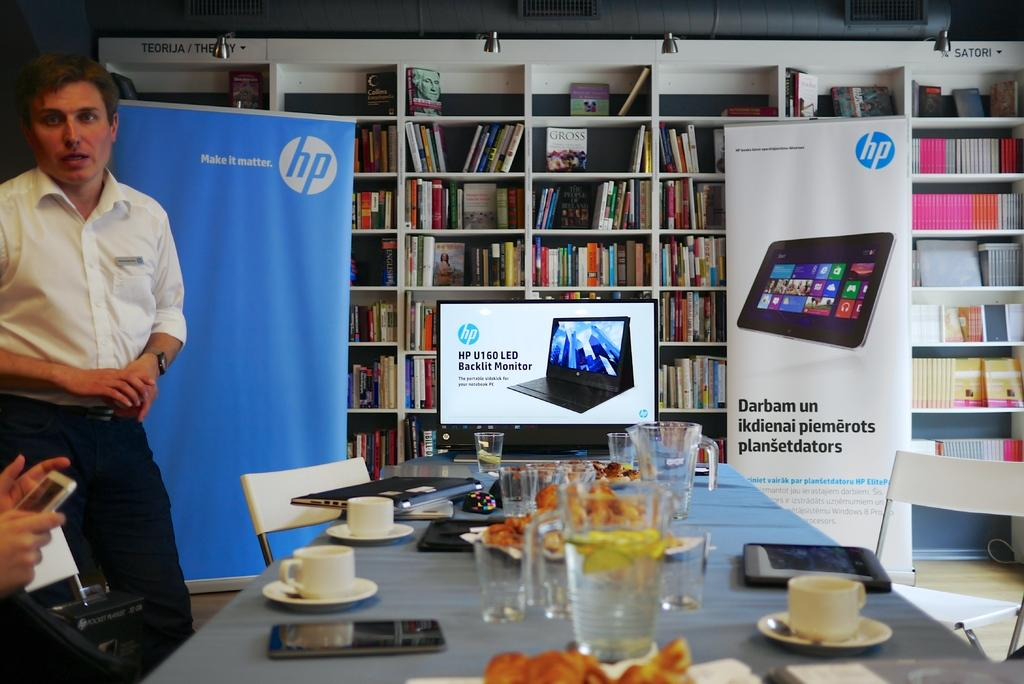<image>
Describe the image concisely. an HP demonstration with the backlit monitor for it's laptops 